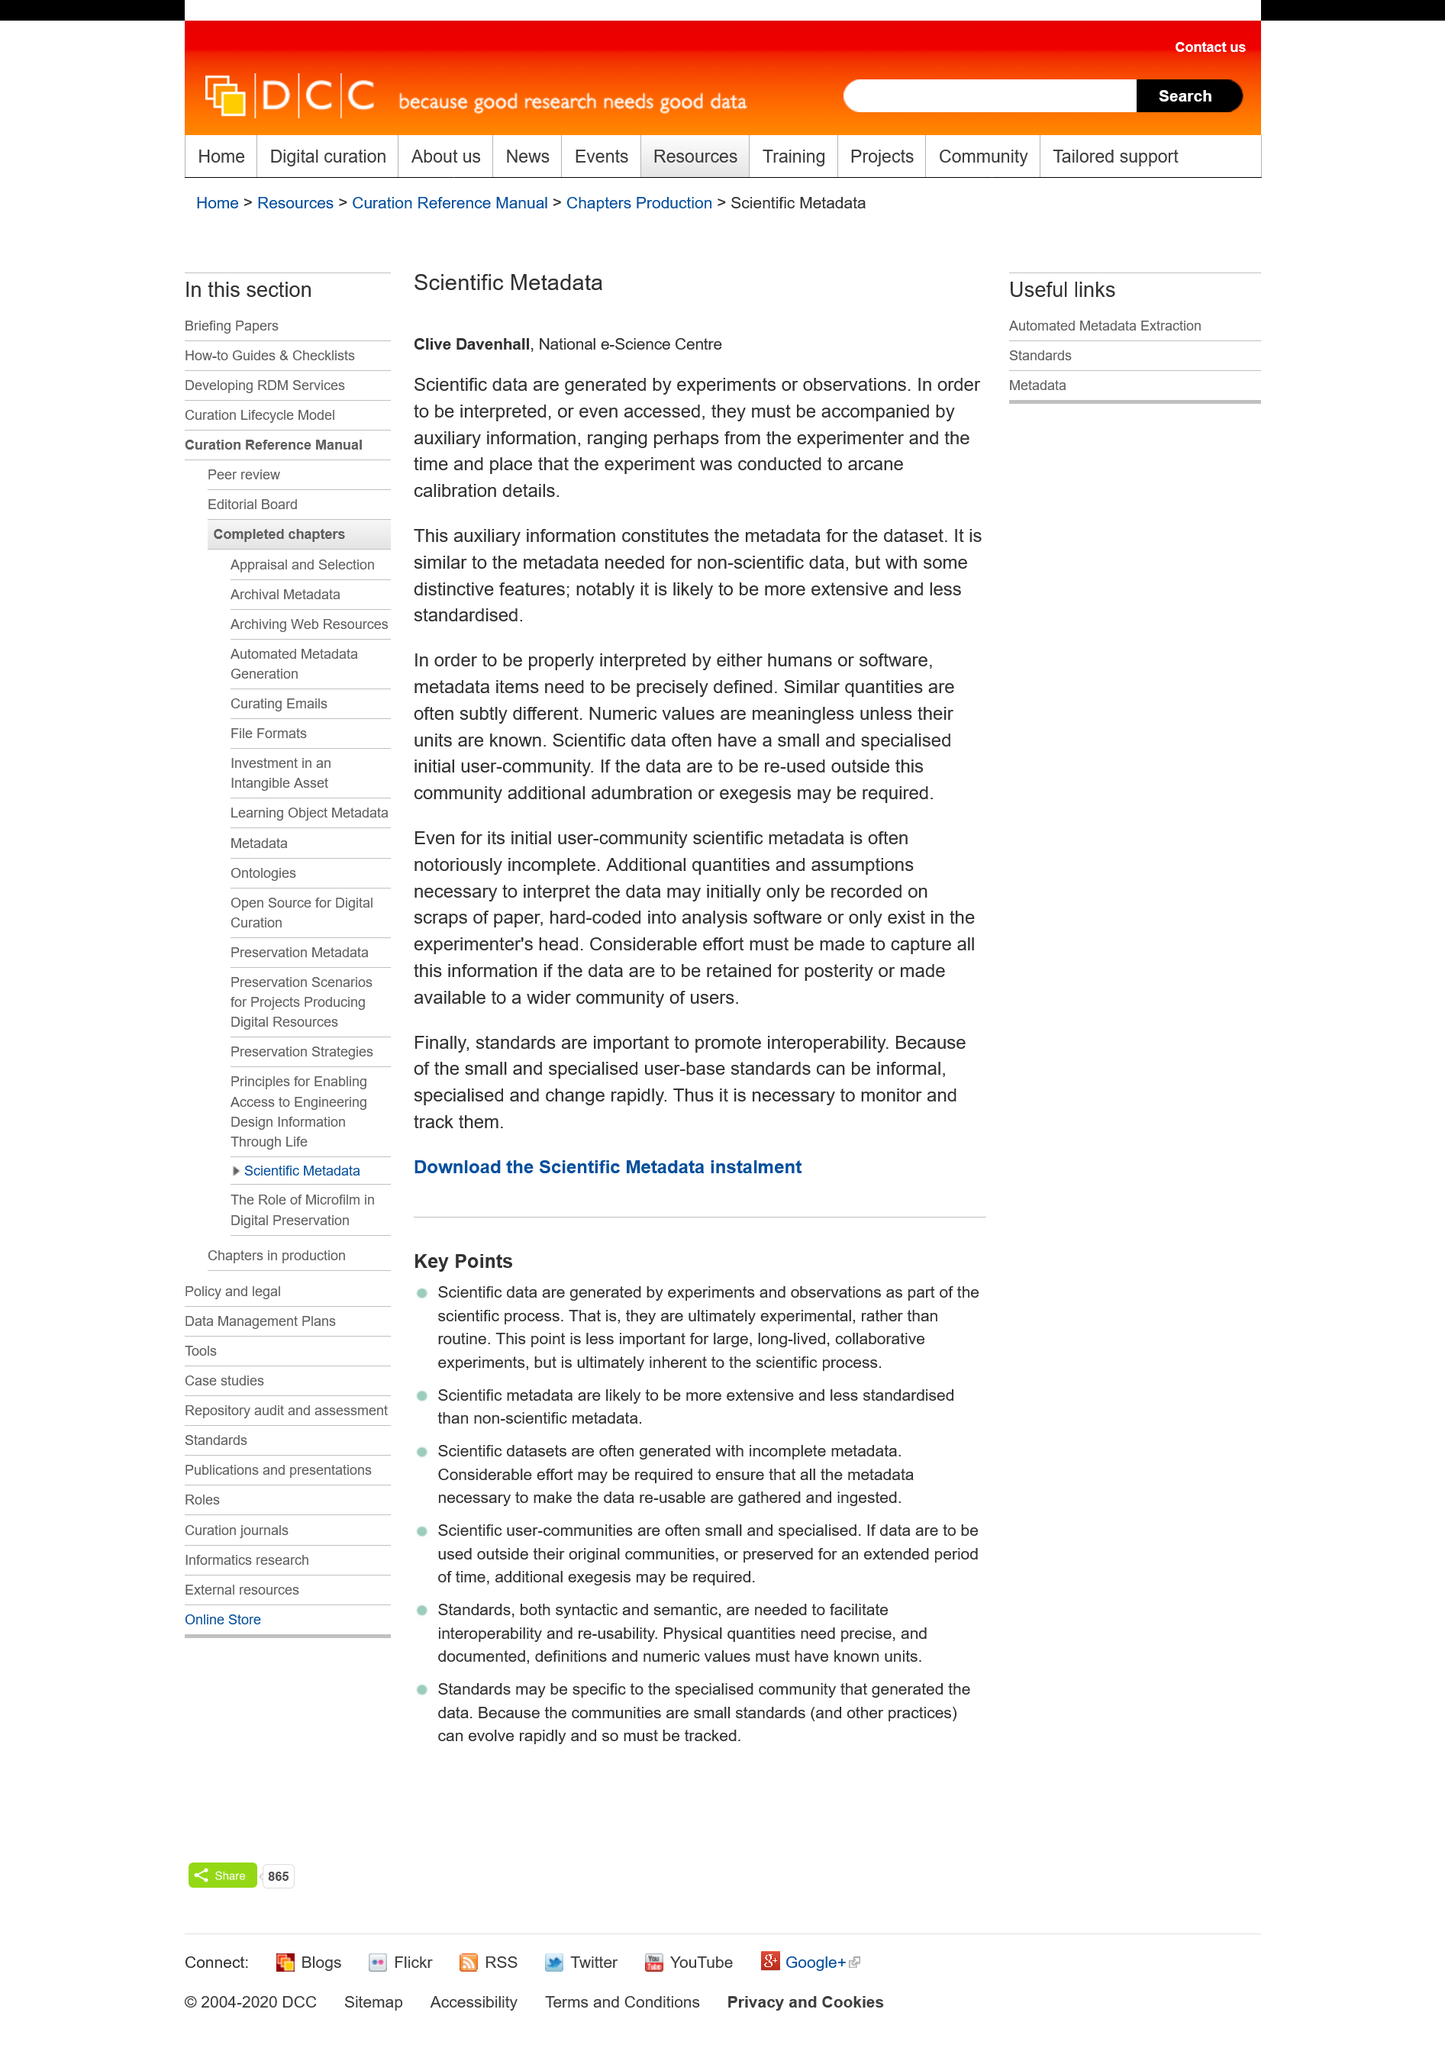Highlight a few significant elements in this photo. Clive Davenhall, from the National e-Science Centre, authored a paper on scientific metadata. The metadata for the data set includes auxiliary information. Scientific data is generated through experiments and observations. 